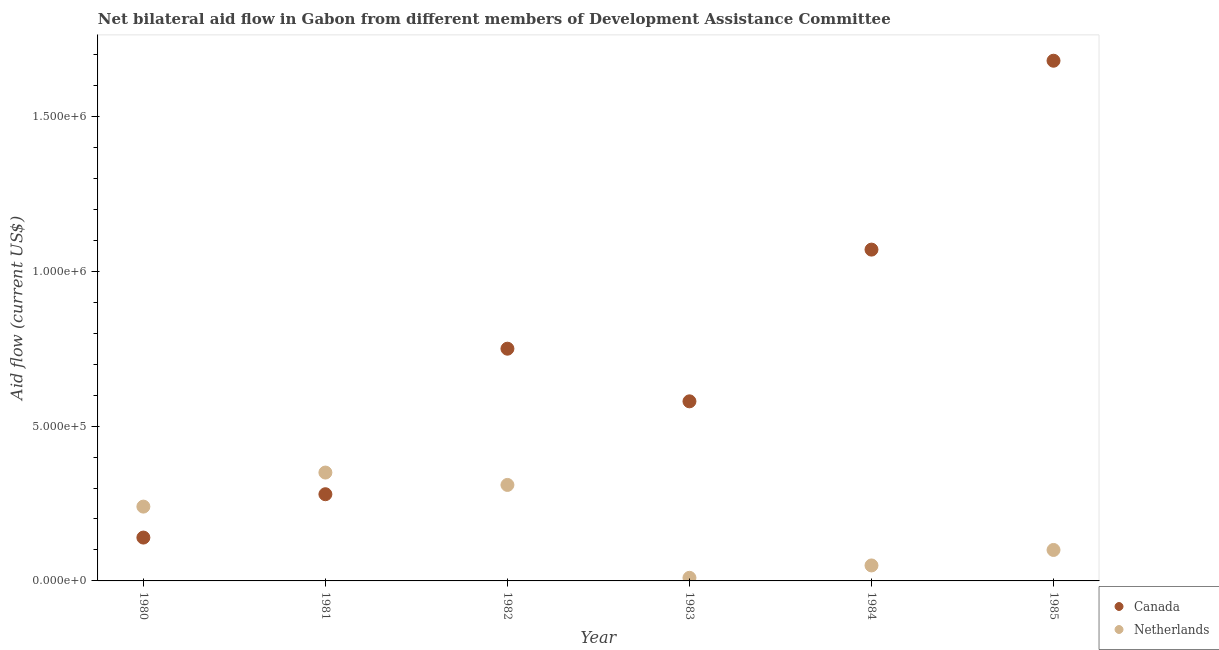How many different coloured dotlines are there?
Provide a short and direct response. 2. Is the number of dotlines equal to the number of legend labels?
Keep it short and to the point. Yes. What is the amount of aid given by canada in 1981?
Offer a very short reply. 2.80e+05. Across all years, what is the maximum amount of aid given by canada?
Provide a short and direct response. 1.68e+06. Across all years, what is the minimum amount of aid given by canada?
Offer a terse response. 1.40e+05. In which year was the amount of aid given by canada maximum?
Your answer should be very brief. 1985. In which year was the amount of aid given by canada minimum?
Ensure brevity in your answer.  1980. What is the total amount of aid given by canada in the graph?
Make the answer very short. 4.50e+06. What is the difference between the amount of aid given by netherlands in 1981 and that in 1983?
Offer a terse response. 3.40e+05. What is the difference between the amount of aid given by netherlands in 1982 and the amount of aid given by canada in 1984?
Keep it short and to the point. -7.60e+05. What is the average amount of aid given by netherlands per year?
Offer a terse response. 1.77e+05. In the year 1980, what is the difference between the amount of aid given by canada and amount of aid given by netherlands?
Your response must be concise. -1.00e+05. What is the ratio of the amount of aid given by canada in 1980 to that in 1983?
Make the answer very short. 0.24. Is the difference between the amount of aid given by netherlands in 1980 and 1981 greater than the difference between the amount of aid given by canada in 1980 and 1981?
Provide a succinct answer. Yes. What is the difference between the highest and the lowest amount of aid given by netherlands?
Make the answer very short. 3.40e+05. In how many years, is the amount of aid given by canada greater than the average amount of aid given by canada taken over all years?
Provide a short and direct response. 2. Does the amount of aid given by netherlands monotonically increase over the years?
Ensure brevity in your answer.  No. How many dotlines are there?
Offer a terse response. 2. Does the graph contain any zero values?
Your answer should be very brief. No. What is the title of the graph?
Make the answer very short. Net bilateral aid flow in Gabon from different members of Development Assistance Committee. What is the label or title of the X-axis?
Offer a very short reply. Year. What is the label or title of the Y-axis?
Give a very brief answer. Aid flow (current US$). What is the Aid flow (current US$) in Netherlands in 1980?
Provide a succinct answer. 2.40e+05. What is the Aid flow (current US$) in Netherlands in 1981?
Offer a terse response. 3.50e+05. What is the Aid flow (current US$) in Canada in 1982?
Ensure brevity in your answer.  7.50e+05. What is the Aid flow (current US$) of Netherlands in 1982?
Provide a succinct answer. 3.10e+05. What is the Aid flow (current US$) of Canada in 1983?
Your response must be concise. 5.80e+05. What is the Aid flow (current US$) of Netherlands in 1983?
Make the answer very short. 10000. What is the Aid flow (current US$) in Canada in 1984?
Make the answer very short. 1.07e+06. What is the Aid flow (current US$) of Canada in 1985?
Make the answer very short. 1.68e+06. What is the Aid flow (current US$) in Netherlands in 1985?
Your answer should be very brief. 1.00e+05. Across all years, what is the maximum Aid flow (current US$) in Canada?
Ensure brevity in your answer.  1.68e+06. Across all years, what is the maximum Aid flow (current US$) of Netherlands?
Offer a terse response. 3.50e+05. Across all years, what is the minimum Aid flow (current US$) in Canada?
Provide a succinct answer. 1.40e+05. What is the total Aid flow (current US$) of Canada in the graph?
Provide a succinct answer. 4.50e+06. What is the total Aid flow (current US$) of Netherlands in the graph?
Make the answer very short. 1.06e+06. What is the difference between the Aid flow (current US$) of Canada in 1980 and that in 1981?
Provide a short and direct response. -1.40e+05. What is the difference between the Aid flow (current US$) of Canada in 1980 and that in 1982?
Offer a very short reply. -6.10e+05. What is the difference between the Aid flow (current US$) in Netherlands in 1980 and that in 1982?
Your answer should be very brief. -7.00e+04. What is the difference between the Aid flow (current US$) of Canada in 1980 and that in 1983?
Your answer should be very brief. -4.40e+05. What is the difference between the Aid flow (current US$) in Canada in 1980 and that in 1984?
Ensure brevity in your answer.  -9.30e+05. What is the difference between the Aid flow (current US$) of Canada in 1980 and that in 1985?
Your response must be concise. -1.54e+06. What is the difference between the Aid flow (current US$) of Canada in 1981 and that in 1982?
Your answer should be compact. -4.70e+05. What is the difference between the Aid flow (current US$) in Netherlands in 1981 and that in 1983?
Provide a succinct answer. 3.40e+05. What is the difference between the Aid flow (current US$) of Canada in 1981 and that in 1984?
Your answer should be very brief. -7.90e+05. What is the difference between the Aid flow (current US$) of Netherlands in 1981 and that in 1984?
Make the answer very short. 3.00e+05. What is the difference between the Aid flow (current US$) of Canada in 1981 and that in 1985?
Provide a succinct answer. -1.40e+06. What is the difference between the Aid flow (current US$) in Netherlands in 1981 and that in 1985?
Your response must be concise. 2.50e+05. What is the difference between the Aid flow (current US$) of Canada in 1982 and that in 1983?
Provide a short and direct response. 1.70e+05. What is the difference between the Aid flow (current US$) of Netherlands in 1982 and that in 1983?
Offer a very short reply. 3.00e+05. What is the difference between the Aid flow (current US$) in Canada in 1982 and that in 1984?
Keep it short and to the point. -3.20e+05. What is the difference between the Aid flow (current US$) of Netherlands in 1982 and that in 1984?
Your answer should be very brief. 2.60e+05. What is the difference between the Aid flow (current US$) in Canada in 1982 and that in 1985?
Provide a short and direct response. -9.30e+05. What is the difference between the Aid flow (current US$) in Canada in 1983 and that in 1984?
Your answer should be compact. -4.90e+05. What is the difference between the Aid flow (current US$) in Netherlands in 1983 and that in 1984?
Your answer should be compact. -4.00e+04. What is the difference between the Aid flow (current US$) in Canada in 1983 and that in 1985?
Provide a short and direct response. -1.10e+06. What is the difference between the Aid flow (current US$) of Netherlands in 1983 and that in 1985?
Your response must be concise. -9.00e+04. What is the difference between the Aid flow (current US$) of Canada in 1984 and that in 1985?
Ensure brevity in your answer.  -6.10e+05. What is the difference between the Aid flow (current US$) in Canada in 1980 and the Aid flow (current US$) in Netherlands in 1981?
Ensure brevity in your answer.  -2.10e+05. What is the difference between the Aid flow (current US$) of Canada in 1980 and the Aid flow (current US$) of Netherlands in 1982?
Offer a very short reply. -1.70e+05. What is the difference between the Aid flow (current US$) in Canada in 1980 and the Aid flow (current US$) in Netherlands in 1985?
Give a very brief answer. 4.00e+04. What is the difference between the Aid flow (current US$) in Canada in 1981 and the Aid flow (current US$) in Netherlands in 1982?
Provide a succinct answer. -3.00e+04. What is the difference between the Aid flow (current US$) in Canada in 1981 and the Aid flow (current US$) in Netherlands in 1984?
Give a very brief answer. 2.30e+05. What is the difference between the Aid flow (current US$) in Canada in 1981 and the Aid flow (current US$) in Netherlands in 1985?
Your answer should be compact. 1.80e+05. What is the difference between the Aid flow (current US$) in Canada in 1982 and the Aid flow (current US$) in Netherlands in 1983?
Offer a very short reply. 7.40e+05. What is the difference between the Aid flow (current US$) of Canada in 1982 and the Aid flow (current US$) of Netherlands in 1984?
Keep it short and to the point. 7.00e+05. What is the difference between the Aid flow (current US$) in Canada in 1982 and the Aid flow (current US$) in Netherlands in 1985?
Offer a terse response. 6.50e+05. What is the difference between the Aid flow (current US$) in Canada in 1983 and the Aid flow (current US$) in Netherlands in 1984?
Give a very brief answer. 5.30e+05. What is the difference between the Aid flow (current US$) of Canada in 1983 and the Aid flow (current US$) of Netherlands in 1985?
Your answer should be compact. 4.80e+05. What is the difference between the Aid flow (current US$) in Canada in 1984 and the Aid flow (current US$) in Netherlands in 1985?
Give a very brief answer. 9.70e+05. What is the average Aid flow (current US$) in Canada per year?
Offer a terse response. 7.50e+05. What is the average Aid flow (current US$) of Netherlands per year?
Offer a terse response. 1.77e+05. In the year 1981, what is the difference between the Aid flow (current US$) of Canada and Aid flow (current US$) of Netherlands?
Make the answer very short. -7.00e+04. In the year 1982, what is the difference between the Aid flow (current US$) of Canada and Aid flow (current US$) of Netherlands?
Keep it short and to the point. 4.40e+05. In the year 1983, what is the difference between the Aid flow (current US$) of Canada and Aid flow (current US$) of Netherlands?
Provide a succinct answer. 5.70e+05. In the year 1984, what is the difference between the Aid flow (current US$) in Canada and Aid flow (current US$) in Netherlands?
Provide a succinct answer. 1.02e+06. In the year 1985, what is the difference between the Aid flow (current US$) in Canada and Aid flow (current US$) in Netherlands?
Ensure brevity in your answer.  1.58e+06. What is the ratio of the Aid flow (current US$) of Canada in 1980 to that in 1981?
Provide a short and direct response. 0.5. What is the ratio of the Aid flow (current US$) of Netherlands in 1980 to that in 1981?
Provide a short and direct response. 0.69. What is the ratio of the Aid flow (current US$) of Canada in 1980 to that in 1982?
Give a very brief answer. 0.19. What is the ratio of the Aid flow (current US$) in Netherlands in 1980 to that in 1982?
Your answer should be compact. 0.77. What is the ratio of the Aid flow (current US$) of Canada in 1980 to that in 1983?
Provide a succinct answer. 0.24. What is the ratio of the Aid flow (current US$) in Canada in 1980 to that in 1984?
Offer a very short reply. 0.13. What is the ratio of the Aid flow (current US$) of Netherlands in 1980 to that in 1984?
Offer a very short reply. 4.8. What is the ratio of the Aid flow (current US$) of Canada in 1980 to that in 1985?
Provide a succinct answer. 0.08. What is the ratio of the Aid flow (current US$) of Netherlands in 1980 to that in 1985?
Your answer should be very brief. 2.4. What is the ratio of the Aid flow (current US$) in Canada in 1981 to that in 1982?
Keep it short and to the point. 0.37. What is the ratio of the Aid flow (current US$) of Netherlands in 1981 to that in 1982?
Provide a succinct answer. 1.13. What is the ratio of the Aid flow (current US$) of Canada in 1981 to that in 1983?
Make the answer very short. 0.48. What is the ratio of the Aid flow (current US$) in Canada in 1981 to that in 1984?
Give a very brief answer. 0.26. What is the ratio of the Aid flow (current US$) in Netherlands in 1981 to that in 1985?
Offer a terse response. 3.5. What is the ratio of the Aid flow (current US$) of Canada in 1982 to that in 1983?
Your response must be concise. 1.29. What is the ratio of the Aid flow (current US$) in Netherlands in 1982 to that in 1983?
Ensure brevity in your answer.  31. What is the ratio of the Aid flow (current US$) in Canada in 1982 to that in 1984?
Keep it short and to the point. 0.7. What is the ratio of the Aid flow (current US$) in Netherlands in 1982 to that in 1984?
Your response must be concise. 6.2. What is the ratio of the Aid flow (current US$) of Canada in 1982 to that in 1985?
Ensure brevity in your answer.  0.45. What is the ratio of the Aid flow (current US$) of Canada in 1983 to that in 1984?
Give a very brief answer. 0.54. What is the ratio of the Aid flow (current US$) in Netherlands in 1983 to that in 1984?
Offer a terse response. 0.2. What is the ratio of the Aid flow (current US$) in Canada in 1983 to that in 1985?
Provide a short and direct response. 0.35. What is the ratio of the Aid flow (current US$) of Canada in 1984 to that in 1985?
Offer a terse response. 0.64. What is the ratio of the Aid flow (current US$) of Netherlands in 1984 to that in 1985?
Keep it short and to the point. 0.5. What is the difference between the highest and the second highest Aid flow (current US$) of Canada?
Offer a terse response. 6.10e+05. What is the difference between the highest and the second highest Aid flow (current US$) in Netherlands?
Provide a succinct answer. 4.00e+04. What is the difference between the highest and the lowest Aid flow (current US$) of Canada?
Give a very brief answer. 1.54e+06. What is the difference between the highest and the lowest Aid flow (current US$) of Netherlands?
Provide a succinct answer. 3.40e+05. 